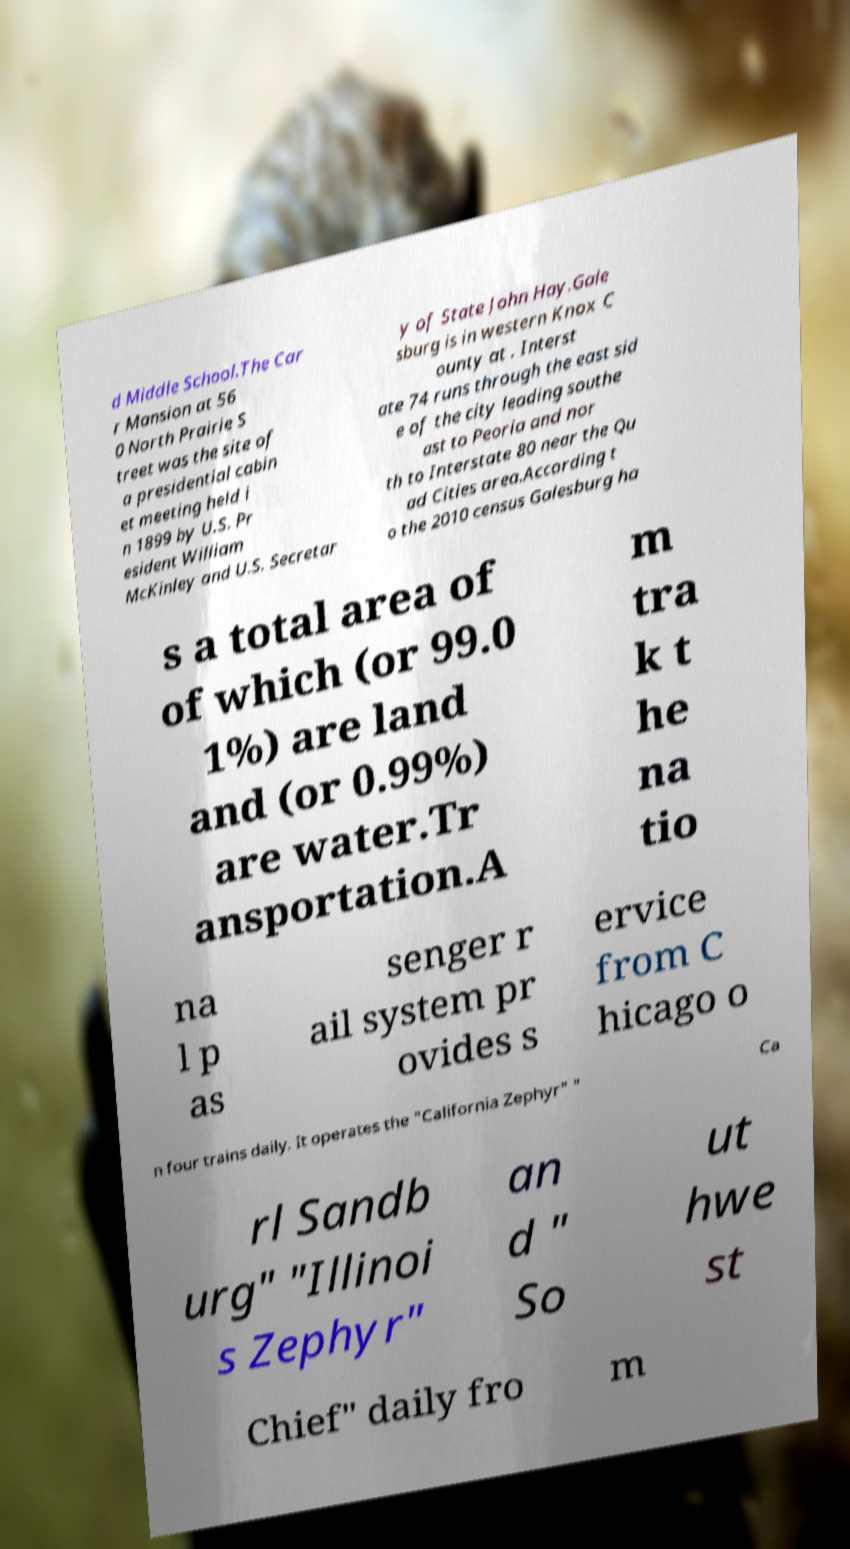What messages or text are displayed in this image? I need them in a readable, typed format. d Middle School.The Car r Mansion at 56 0 North Prairie S treet was the site of a presidential cabin et meeting held i n 1899 by U.S. Pr esident William McKinley and U.S. Secretar y of State John Hay.Gale sburg is in western Knox C ounty at . Interst ate 74 runs through the east sid e of the city leading southe ast to Peoria and nor th to Interstate 80 near the Qu ad Cities area.According t o the 2010 census Galesburg ha s a total area of of which (or 99.0 1%) are land and (or 0.99%) are water.Tr ansportation.A m tra k t he na tio na l p as senger r ail system pr ovides s ervice from C hicago o n four trains daily. It operates the "California Zephyr" " Ca rl Sandb urg" "Illinoi s Zephyr" an d " So ut hwe st Chief" daily fro m 